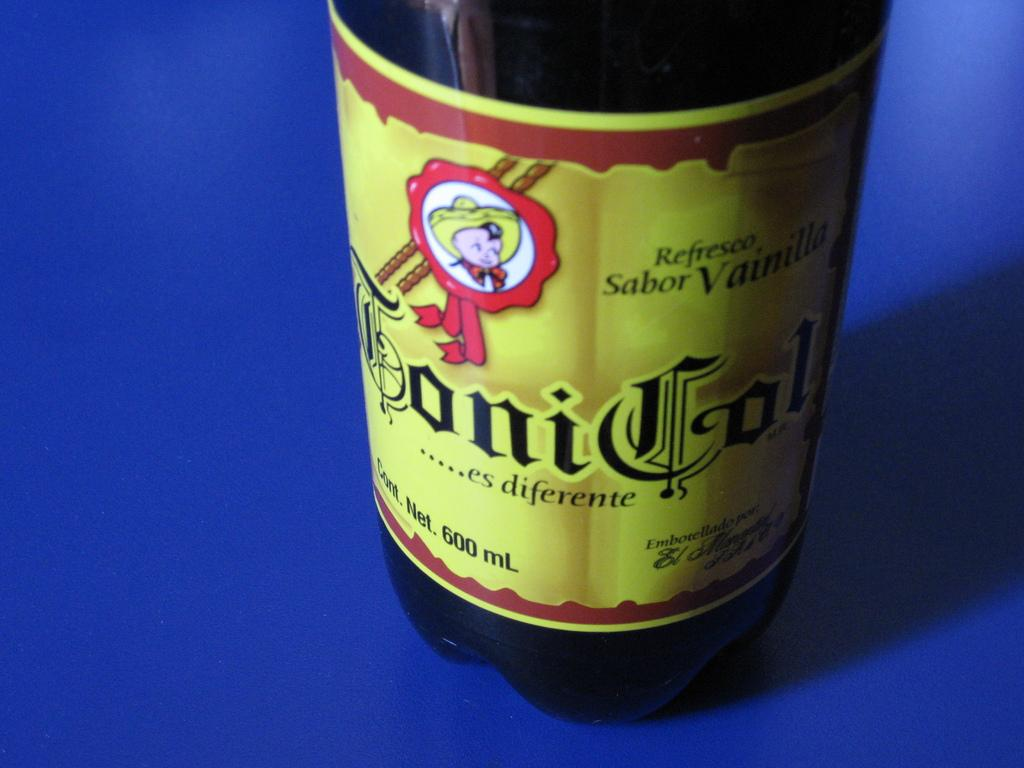<image>
Describe the image concisely. A bottle showing a small child wearing a hat that states refesco sabor vainilla 